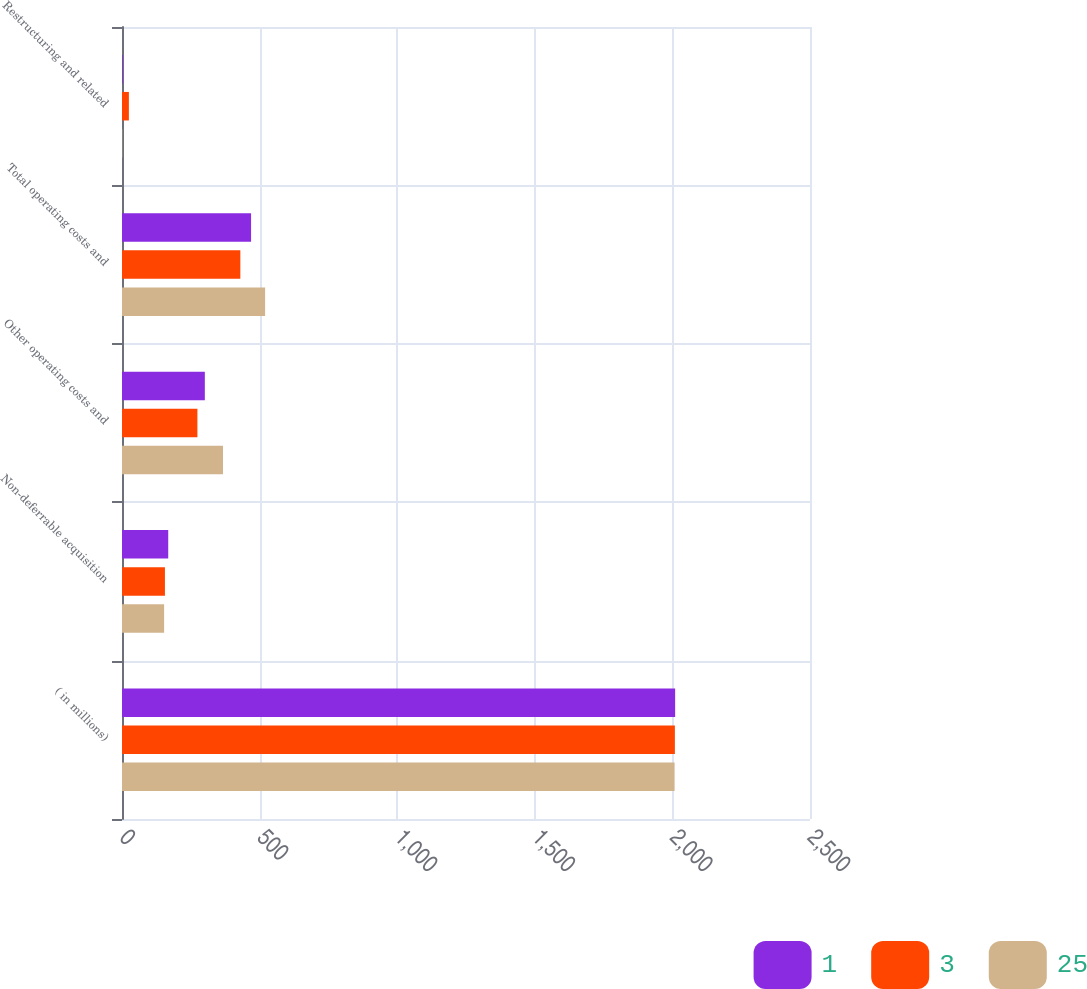Convert chart. <chart><loc_0><loc_0><loc_500><loc_500><stacked_bar_chart><ecel><fcel>( in millions)<fcel>Non-deferrable acquisition<fcel>Other operating costs and<fcel>Total operating costs and<fcel>Restructuring and related<nl><fcel>1<fcel>2010<fcel>168<fcel>301<fcel>469<fcel>3<nl><fcel>3<fcel>2009<fcel>156<fcel>274<fcel>430<fcel>25<nl><fcel>25<fcel>2008<fcel>153<fcel>367<fcel>520<fcel>1<nl></chart> 